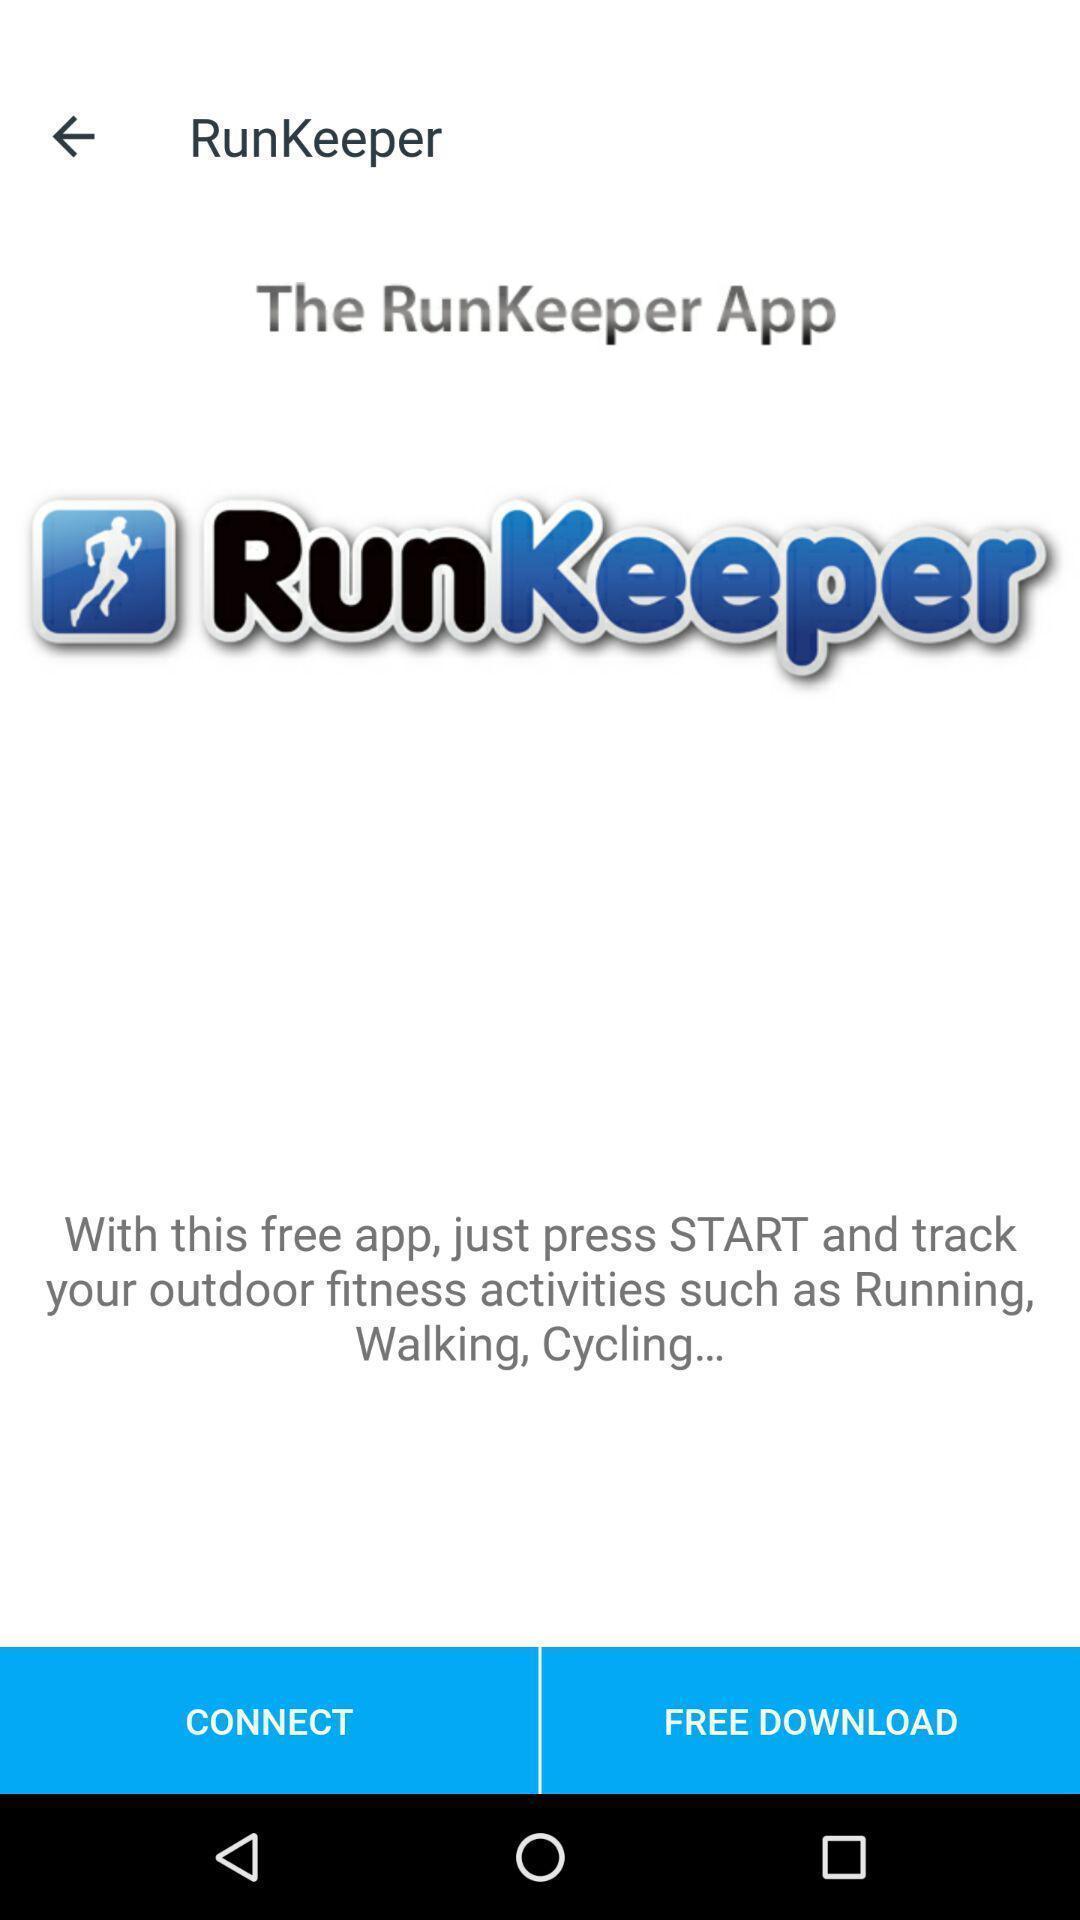Describe the visual elements of this screenshot. Welcome page for the health fitness app. 